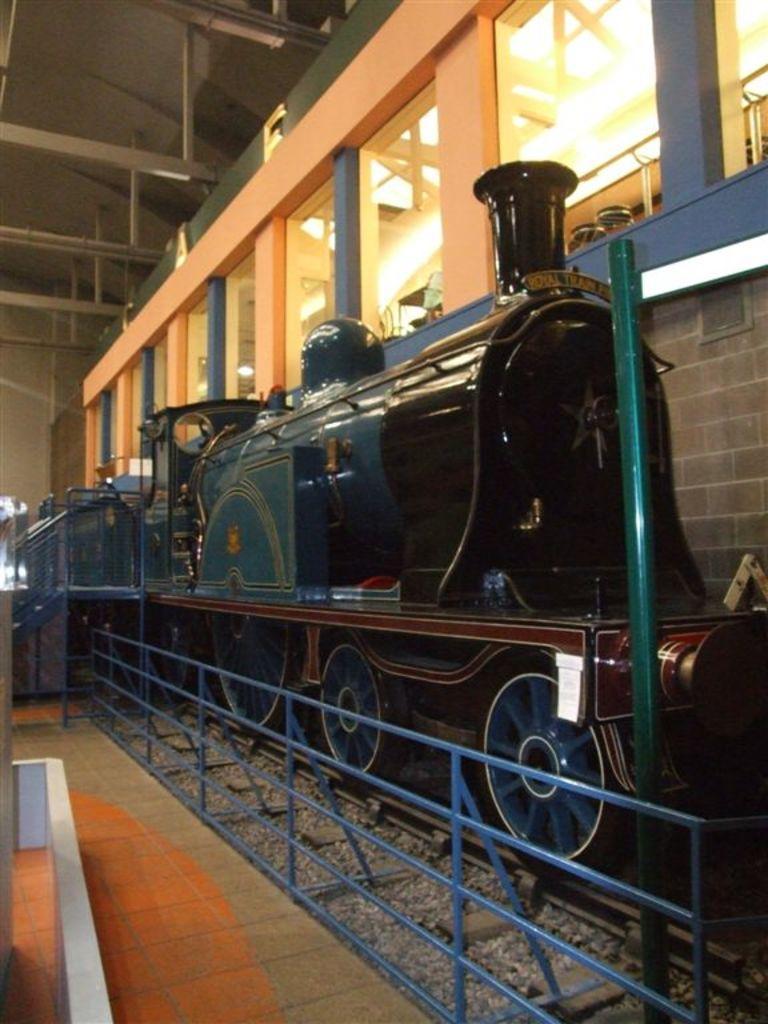Describe this image in one or two sentences. In this image I can see a train on the track, fence. In the background I can see a wall, windows and a rooftop. This image is taken may be in a factory. 